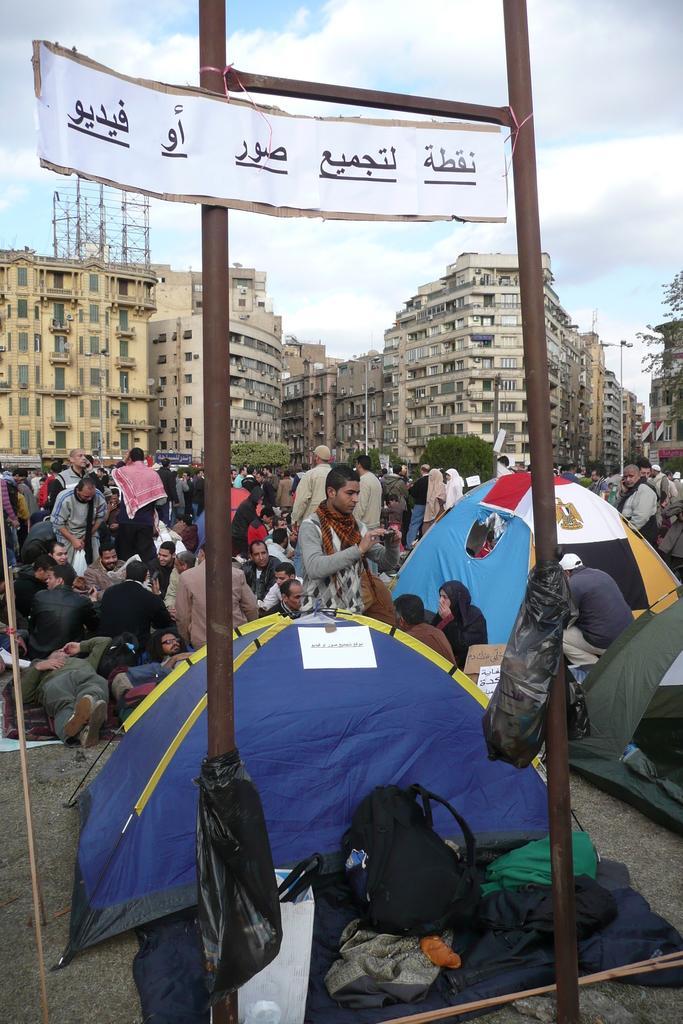In one or two sentences, can you explain what this image depicts? In this picture we can see a group of people, tents, bags, clothes on the ground, poles, buildings, trees and some objects and in the background we can see the sky. 